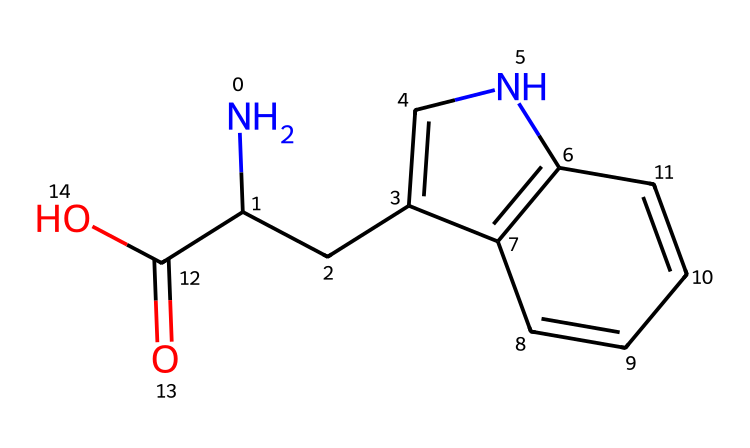What is the molecular formula of serotonin? The SMILES representation indicates the presence of carbon (C), hydrogen (H), nitrogen (N), and oxygen (O). Counting the atoms gives C10, H12, N2, O2. Hence, the molecular formula is derived from these counts.
Answer: C10H12N2O2 How many rings are present in the structure? By analyzing the SMILES notation, we see two 'C' atoms linked with numbers indicating ring closures (1 and 2). Hence, there are two rings in the structure.
Answer: 2 What functional groups are present in this molecule? In this structure, we can identify a carboxylic acid functional group (C(=O)O) and an amine group (NC). These are characteristic functional groups seen in serotonin.
Answer: carboxylic acid and amine What is the connectivity of the nitrogen atoms in serotonin? The SMILES shows one nitrogen is part of an amine (NC) and the other is in a cyclic structure (C1=CNC). Thus, there are two nitrogen atoms with different types of connectivity.
Answer: 2 nitrogen atoms Which part of this molecule is likely responsible for its interaction with receptors? The cyclic structure combined with the amine functionality suggests that the nitrogen atom in the cyclic portion interacts with receptors, as many neurotransmitters and hormones do.
Answer: cyclic structure with amine How does the presence of the carboxylic acid group affect serotonin’s solubility? The carboxylic acid group increases hydrophilicity, allowing better solubility in polar solvents like water. This is due to the ability of the group to form hydrogen bonds.
Answer: increases solubility 